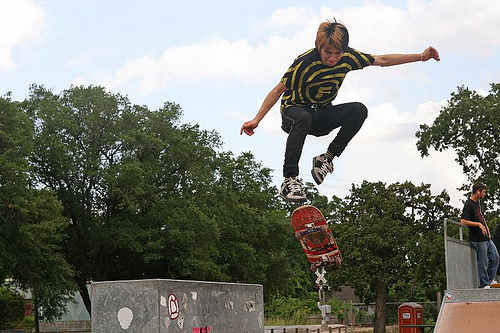<image>
Is the gound under the man? Yes. The gound is positioned underneath the man, with the man above it in the vertical space. Where is the tree in relation to the man? Is it behind the man? Yes. From this viewpoint, the tree is positioned behind the man, with the man partially or fully occluding the tree. 